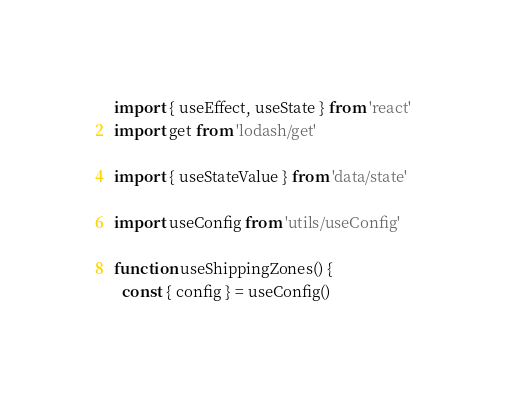<code> <loc_0><loc_0><loc_500><loc_500><_JavaScript_>import { useEffect, useState } from 'react'
import get from 'lodash/get'

import { useStateValue } from 'data/state'

import useConfig from 'utils/useConfig'

function useShippingZones() {
  const { config } = useConfig()</code> 